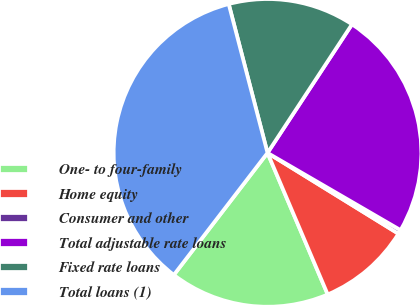<chart> <loc_0><loc_0><loc_500><loc_500><pie_chart><fcel>One- to four-family<fcel>Home equity<fcel>Consumer and other<fcel>Total adjustable rate loans<fcel>Fixed rate loans<fcel>Total loans (1)<nl><fcel>16.82%<fcel>9.8%<fcel>0.43%<fcel>24.12%<fcel>13.31%<fcel>35.52%<nl></chart> 